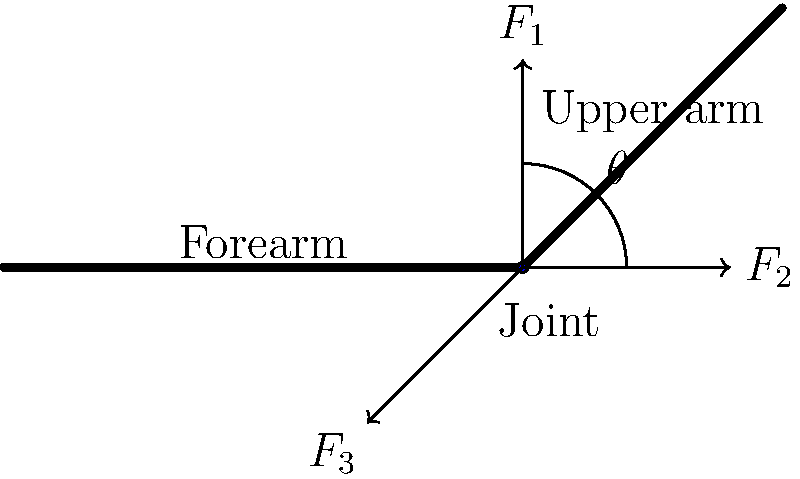In the prosthetic arm joint shown above, three forces act on the joint: $F_1$ vertically upward, $F_2$ horizontally to the right, and $F_3$ at an angle $\theta$ below the horizontal. If $F_1 = 100$ N, $F_2 = 75$ N, and $\theta = 30°$, what should the magnitude of $F_3$ be for the joint to be in equilibrium? To solve this problem, we'll use the conditions for equilibrium and follow these steps:

1) For a body to be in equilibrium, the sum of all forces must be zero in both x and y directions.

2) Let's break $F_3$ into its x and y components:
   $F_{3x} = F_3 \cos(30°)$
   $F_{3y} = F_3 \sin(30°)$

3) Now, let's sum the forces in the x-direction:
   $$\sum F_x = 0$$
   $$F_2 - F_3 \cos(30°) = 0$$
   $$75 - F_3 \cos(30°) = 0$$

4) Sum the forces in the y-direction:
   $$\sum F_y = 0$$
   $$F_1 - F_3 \sin(30°) = 0$$
   $$100 - F_3 \sin(30°) = 0$$

5) From the y-direction equation:
   $$F_3 \sin(30°) = 100$$
   $$F_3 = \frac{100}{\sin(30°)} = 200 \text{ N}$$

6) We can verify this using the x-direction equation:
   $$75 - 200 \cos(30°) = 75 - 173.2 = -1.8 \approx 0$$

   The small difference is due to rounding in our calculations.
Answer: $F_3 = 200 \text{ N}$ 